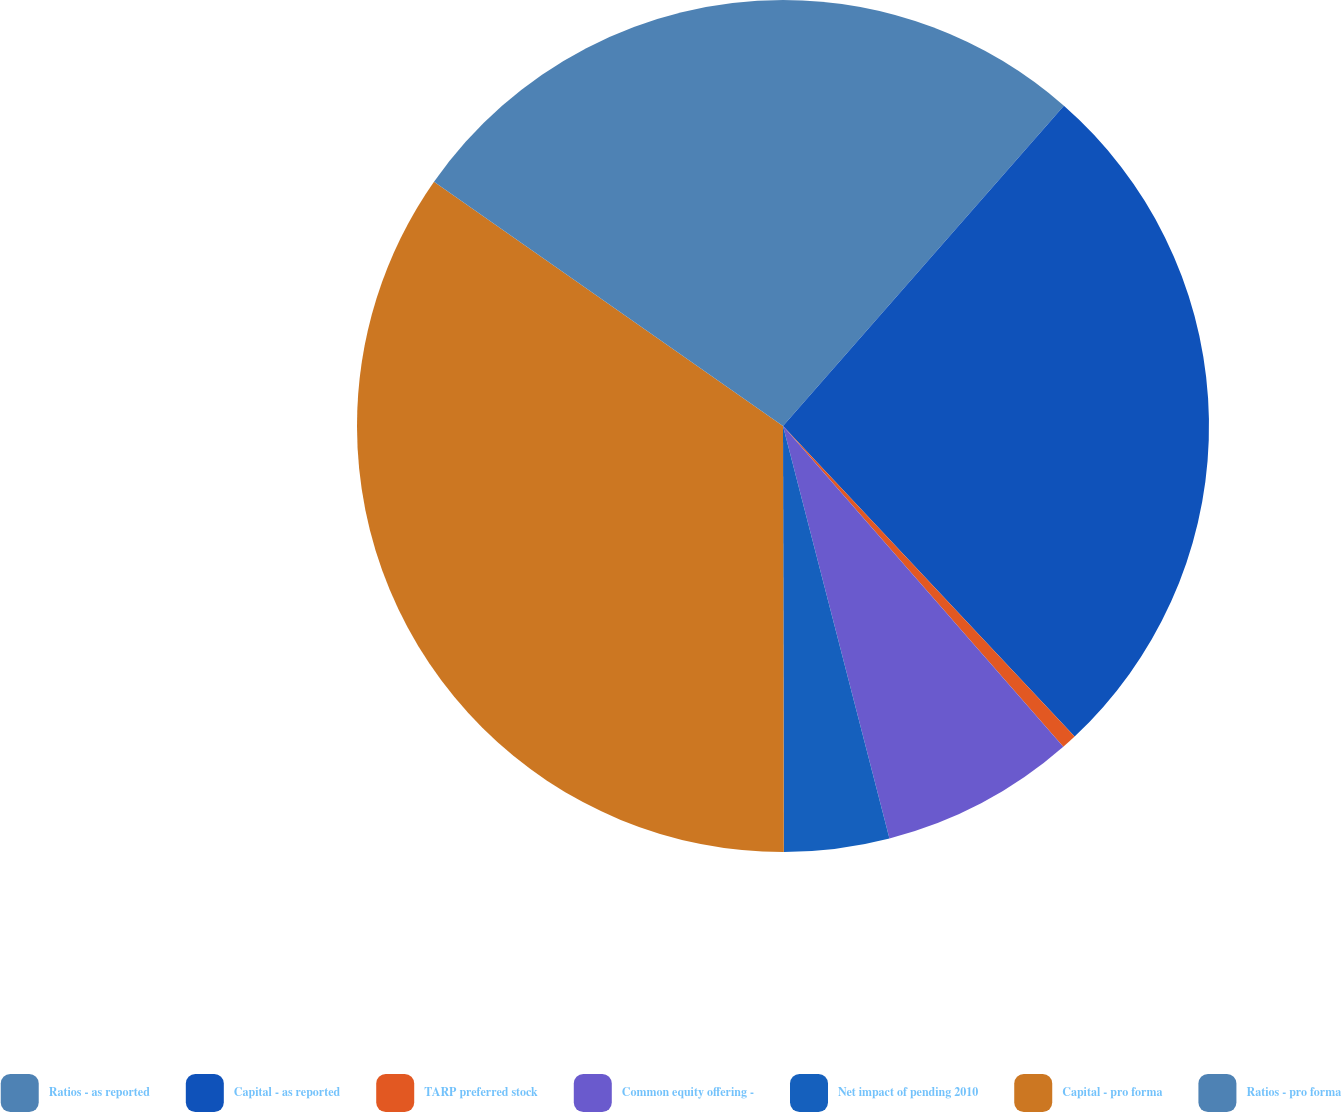<chart> <loc_0><loc_0><loc_500><loc_500><pie_chart><fcel>Ratios - as reported<fcel>Capital - as reported<fcel>TARP preferred stock<fcel>Common equity offering -<fcel>Net impact of pending 2010<fcel>Capital - pro forma<fcel>Ratios - pro forma<nl><fcel>11.46%<fcel>26.54%<fcel>0.57%<fcel>7.41%<fcel>3.99%<fcel>34.75%<fcel>15.28%<nl></chart> 